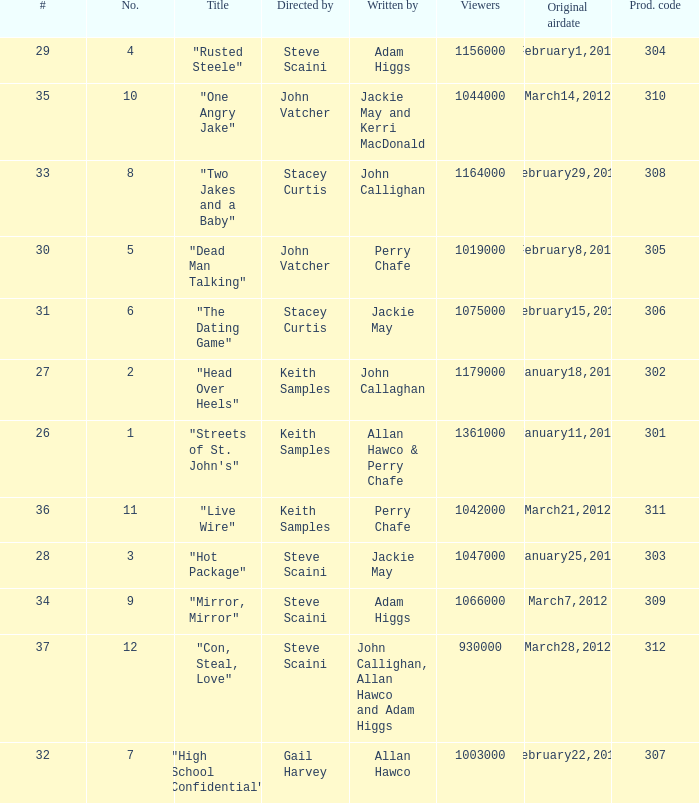What is the total number of films directy and written by john callaghan? 1.0. 